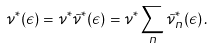Convert formula to latex. <formula><loc_0><loc_0><loc_500><loc_500>\nu ^ { * } ( \epsilon ) = \nu ^ { * } \tilde { \nu } ^ { * } ( \epsilon ) = \nu ^ { * } \sum _ { n } \tilde { \nu } _ { n } ^ { * } ( \epsilon ) \, .</formula> 